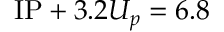<formula> <loc_0><loc_0><loc_500><loc_500>I P + 3 . 2 U _ { p } = 6 . 8</formula> 